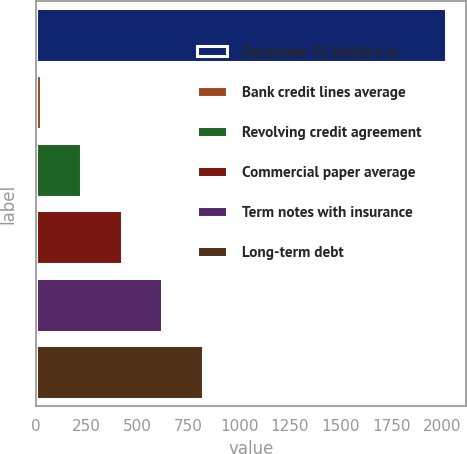Convert chart to OTSL. <chart><loc_0><loc_0><loc_500><loc_500><bar_chart><fcel>December 31 (dollars in<fcel>Bank credit lines average<fcel>Revolving credit agreement<fcel>Commercial paper average<fcel>Term notes with insurance<fcel>Long-term debt<nl><fcel>2016<fcel>23.6<fcel>222.84<fcel>422.08<fcel>621.32<fcel>820.56<nl></chart> 